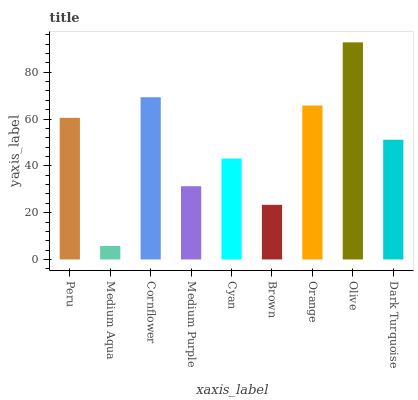Is Medium Aqua the minimum?
Answer yes or no. Yes. Is Olive the maximum?
Answer yes or no. Yes. Is Cornflower the minimum?
Answer yes or no. No. Is Cornflower the maximum?
Answer yes or no. No. Is Cornflower greater than Medium Aqua?
Answer yes or no. Yes. Is Medium Aqua less than Cornflower?
Answer yes or no. Yes. Is Medium Aqua greater than Cornflower?
Answer yes or no. No. Is Cornflower less than Medium Aqua?
Answer yes or no. No. Is Dark Turquoise the high median?
Answer yes or no. Yes. Is Dark Turquoise the low median?
Answer yes or no. Yes. Is Olive the high median?
Answer yes or no. No. Is Brown the low median?
Answer yes or no. No. 